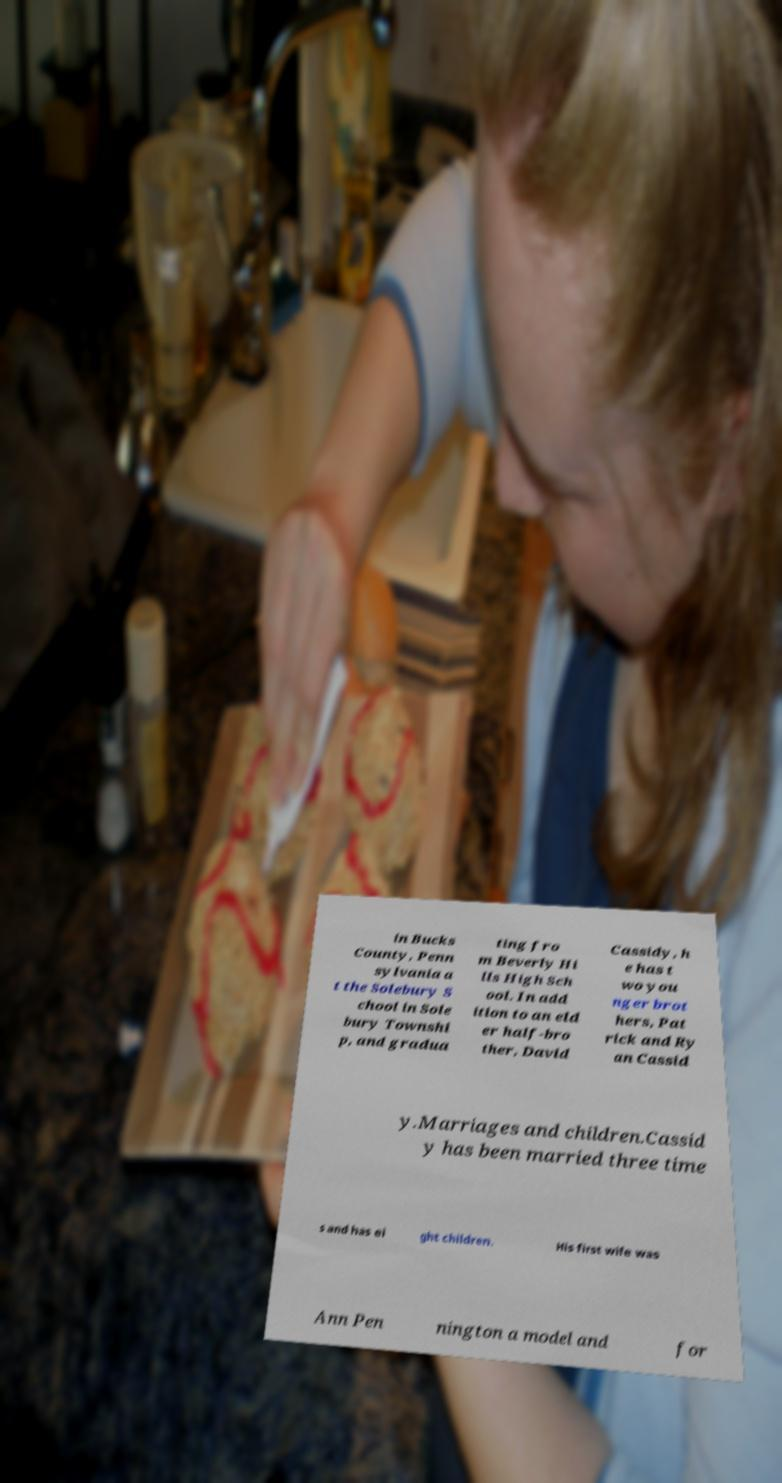Please identify and transcribe the text found in this image. in Bucks County, Penn sylvania a t the Solebury S chool in Sole bury Townshi p, and gradua ting fro m Beverly Hi lls High Sch ool. In add ition to an eld er half-bro ther, David Cassidy, h e has t wo you nger brot hers, Pat rick and Ry an Cassid y.Marriages and children.Cassid y has been married three time s and has ei ght children. His first wife was Ann Pen nington a model and for 